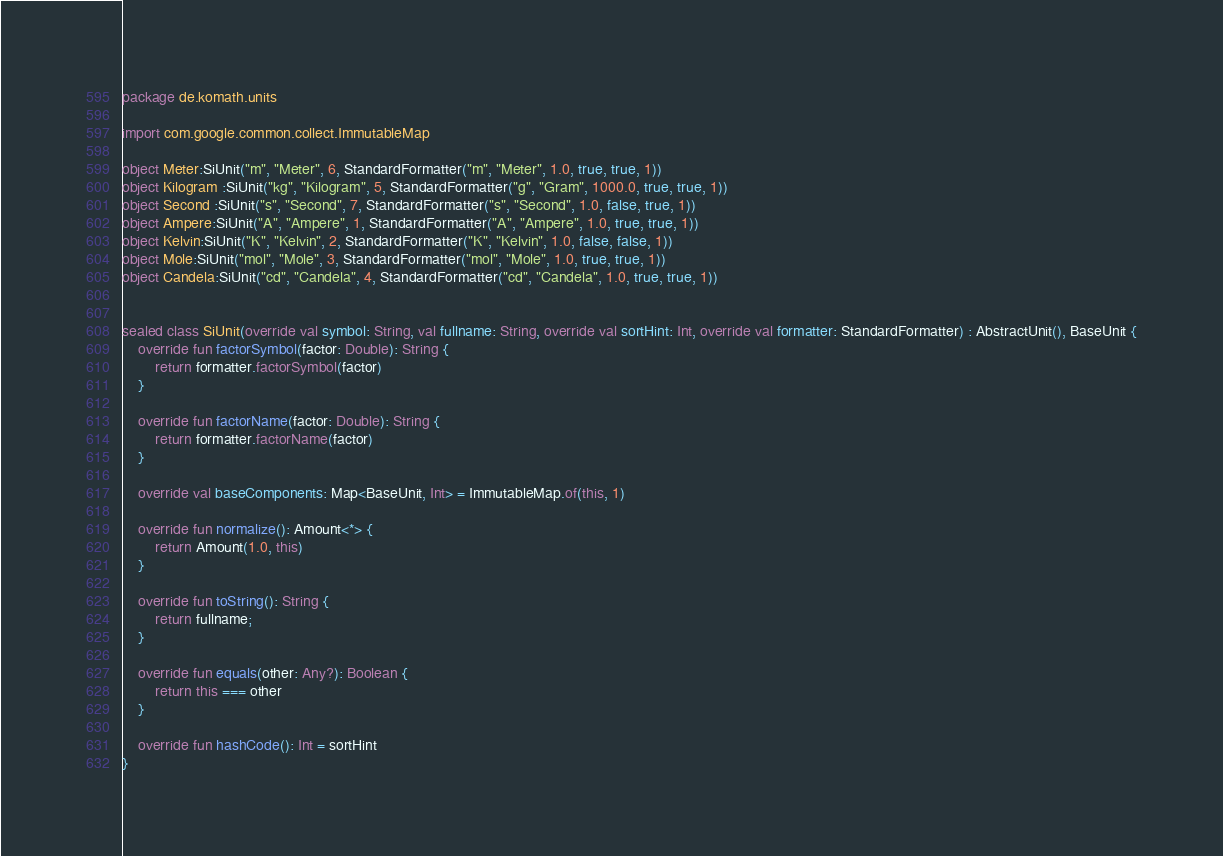Convert code to text. <code><loc_0><loc_0><loc_500><loc_500><_Kotlin_>package de.komath.units

import com.google.common.collect.ImmutableMap

object Meter:SiUnit("m", "Meter", 6, StandardFormatter("m", "Meter", 1.0, true, true, 1))
object Kilogram :SiUnit("kg", "Kilogram", 5, StandardFormatter("g", "Gram", 1000.0, true, true, 1))
object Second :SiUnit("s", "Second", 7, StandardFormatter("s", "Second", 1.0, false, true, 1))
object Ampere:SiUnit("A", "Ampere", 1, StandardFormatter("A", "Ampere", 1.0, true, true, 1))
object Kelvin:SiUnit("K", "Kelvin", 2, StandardFormatter("K", "Kelvin", 1.0, false, false, 1))
object Mole:SiUnit("mol", "Mole", 3, StandardFormatter("mol", "Mole", 1.0, true, true, 1))
object Candela:SiUnit("cd", "Candela", 4, StandardFormatter("cd", "Candela", 1.0, true, true, 1))


sealed class SiUnit(override val symbol: String, val fullname: String, override val sortHint: Int, override val formatter: StandardFormatter) : AbstractUnit(), BaseUnit {
    override fun factorSymbol(factor: Double): String {
        return formatter.factorSymbol(factor)
    }

    override fun factorName(factor: Double): String {
        return formatter.factorName(factor)
    }

    override val baseComponents: Map<BaseUnit, Int> = ImmutableMap.of(this, 1)

    override fun normalize(): Amount<*> {
        return Amount(1.0, this)
    }

    override fun toString(): String {
        return fullname;
    }

    override fun equals(other: Any?): Boolean {
        return this === other
    }

    override fun hashCode(): Int = sortHint
}

</code> 